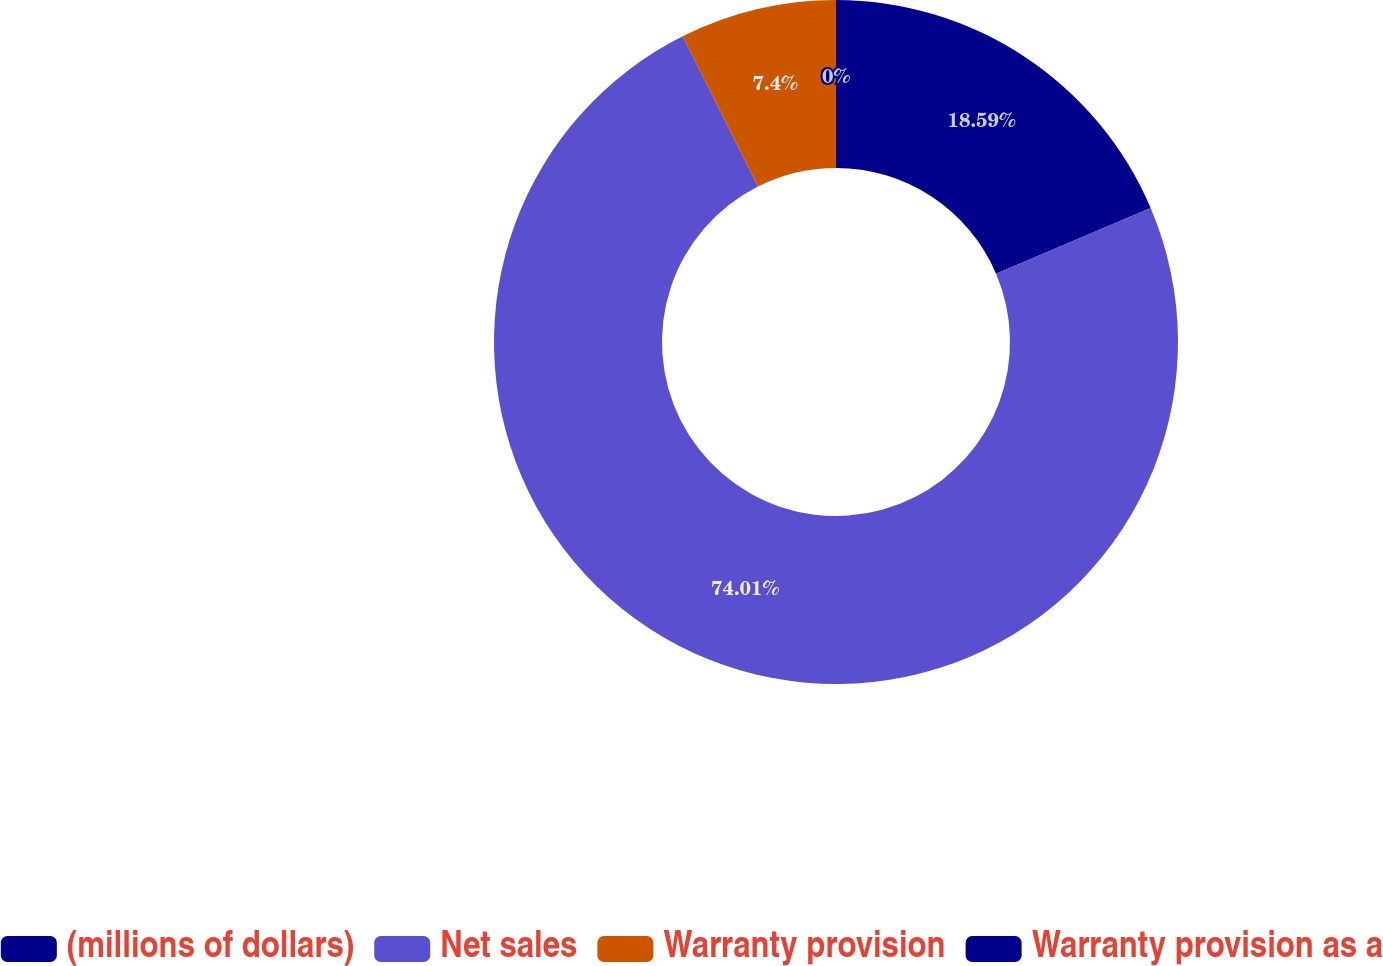Convert chart to OTSL. <chart><loc_0><loc_0><loc_500><loc_500><pie_chart><fcel>(millions of dollars)<fcel>Net sales<fcel>Warranty provision<fcel>Warranty provision as a<nl><fcel>18.59%<fcel>74.01%<fcel>7.4%<fcel>0.0%<nl></chart> 